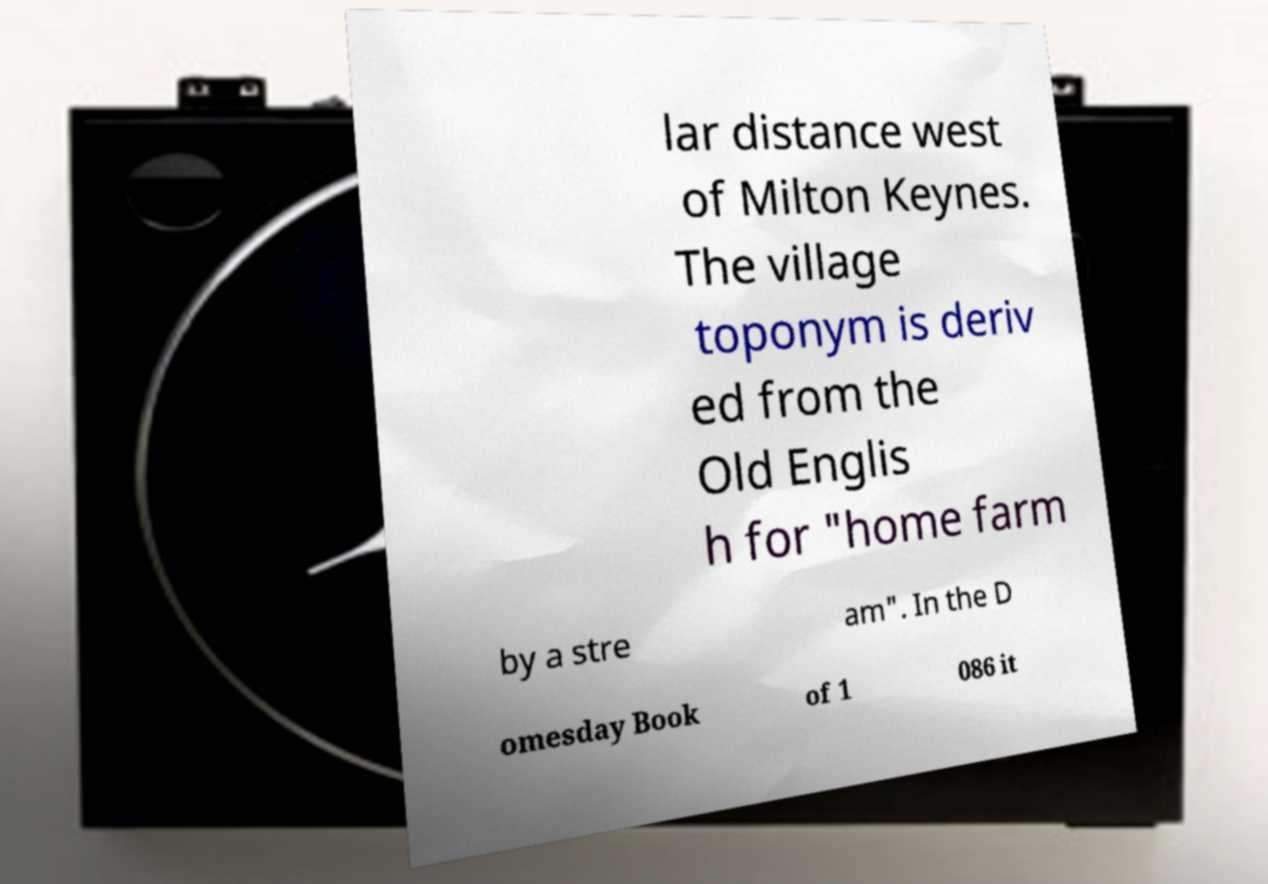Can you read and provide the text displayed in the image?This photo seems to have some interesting text. Can you extract and type it out for me? lar distance west of Milton Keynes. The village toponym is deriv ed from the Old Englis h for "home farm by a stre am". In the D omesday Book of 1 086 it 